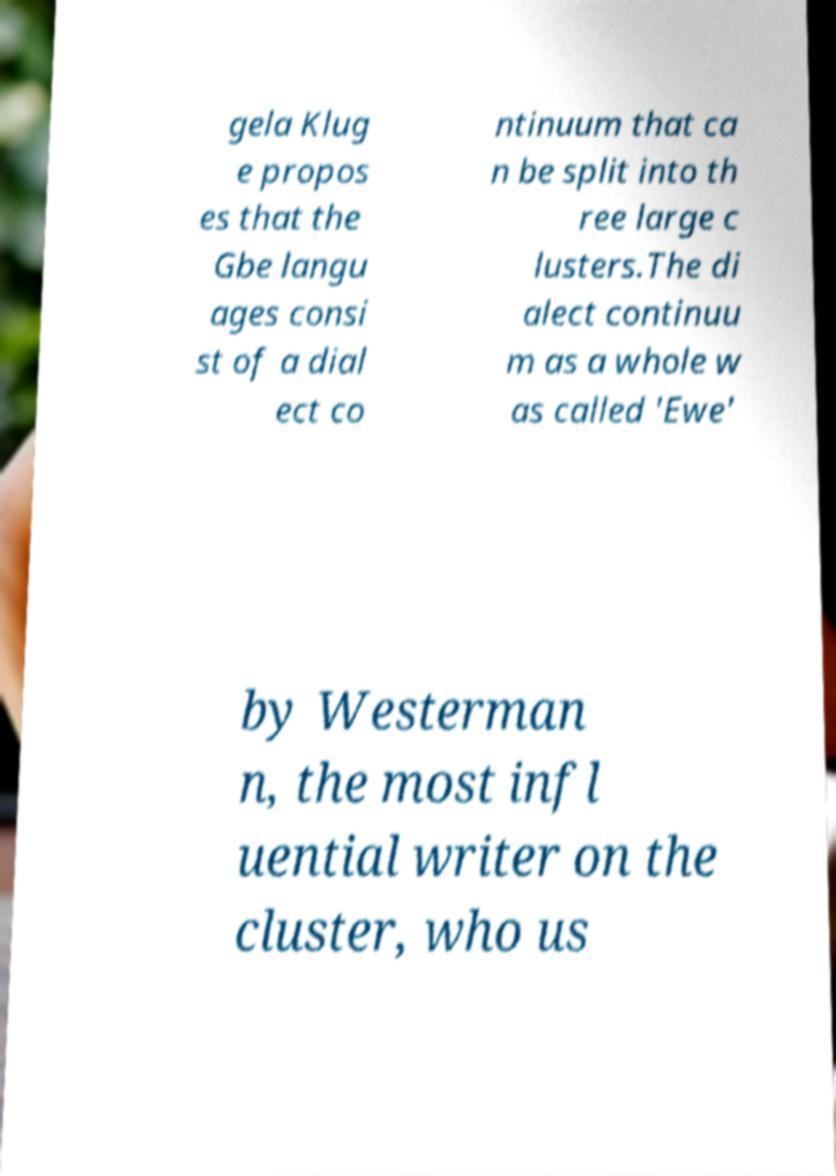There's text embedded in this image that I need extracted. Can you transcribe it verbatim? gela Klug e propos es that the Gbe langu ages consi st of a dial ect co ntinuum that ca n be split into th ree large c lusters.The di alect continuu m as a whole w as called 'Ewe' by Westerman n, the most infl uential writer on the cluster, who us 